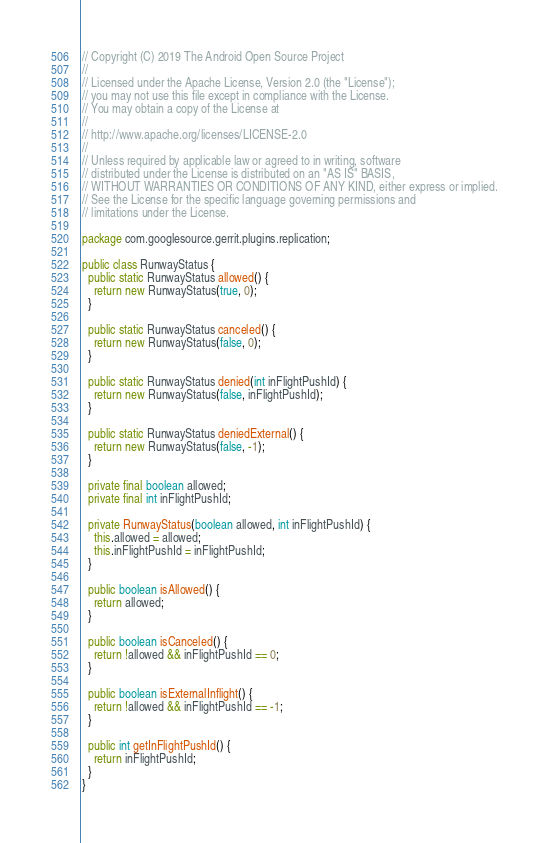<code> <loc_0><loc_0><loc_500><loc_500><_Java_>// Copyright (C) 2019 The Android Open Source Project
//
// Licensed under the Apache License, Version 2.0 (the "License");
// you may not use this file except in compliance with the License.
// You may obtain a copy of the License at
//
// http://www.apache.org/licenses/LICENSE-2.0
//
// Unless required by applicable law or agreed to in writing, software
// distributed under the License is distributed on an "AS IS" BASIS,
// WITHOUT WARRANTIES OR CONDITIONS OF ANY KIND, either express or implied.
// See the License for the specific language governing permissions and
// limitations under the License.

package com.googlesource.gerrit.plugins.replication;

public class RunwayStatus {
  public static RunwayStatus allowed() {
    return new RunwayStatus(true, 0);
  }

  public static RunwayStatus canceled() {
    return new RunwayStatus(false, 0);
  }

  public static RunwayStatus denied(int inFlightPushId) {
    return new RunwayStatus(false, inFlightPushId);
  }

  public static RunwayStatus deniedExternal() {
    return new RunwayStatus(false, -1);
  }

  private final boolean allowed;
  private final int inFlightPushId;

  private RunwayStatus(boolean allowed, int inFlightPushId) {
    this.allowed = allowed;
    this.inFlightPushId = inFlightPushId;
  }

  public boolean isAllowed() {
    return allowed;
  }

  public boolean isCanceled() {
    return !allowed && inFlightPushId == 0;
  }

  public boolean isExternalInflight() {
    return !allowed && inFlightPushId == -1;
  }

  public int getInFlightPushId() {
    return inFlightPushId;
  }
}
</code> 